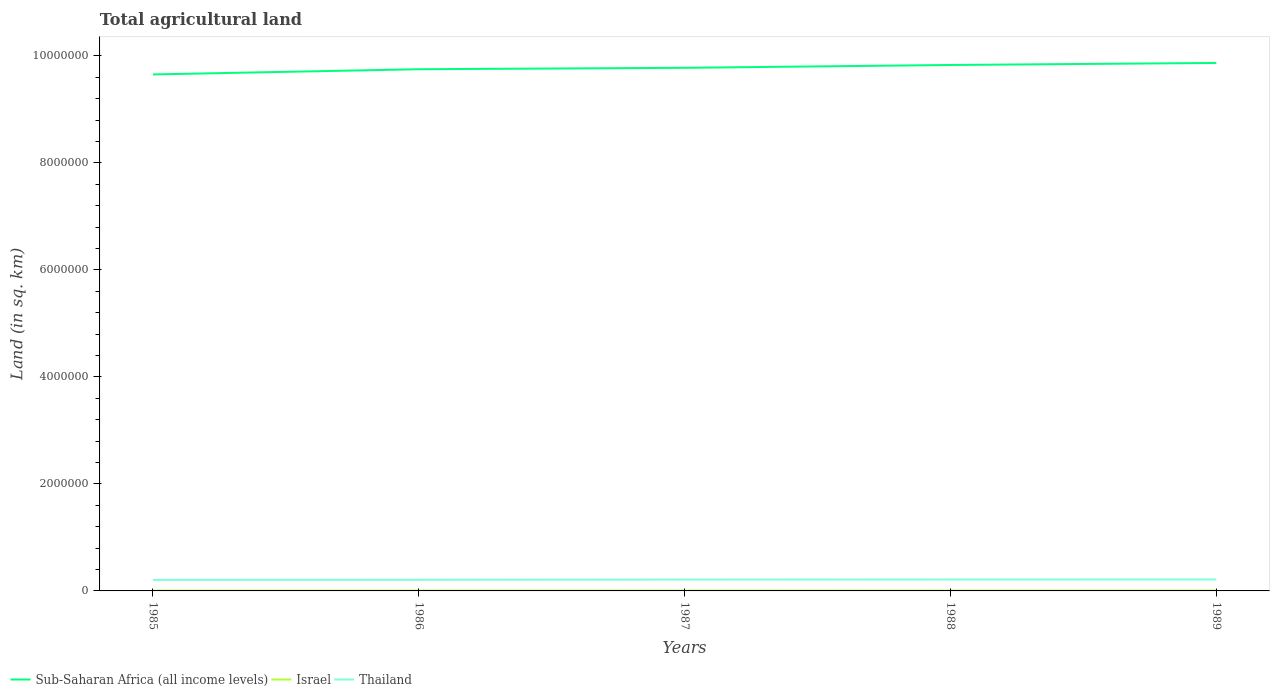How many different coloured lines are there?
Provide a short and direct response. 3. Does the line corresponding to Thailand intersect with the line corresponding to Israel?
Offer a terse response. No. Is the number of lines equal to the number of legend labels?
Offer a very short reply. Yes. Across all years, what is the maximum total agricultural land in Sub-Saharan Africa (all income levels)?
Your response must be concise. 9.65e+06. In which year was the total agricultural land in Israel maximum?
Your response must be concise. 1985. What is the total total agricultural land in Sub-Saharan Africa (all income levels) in the graph?
Your answer should be compact. -2.15e+05. What is the difference between the highest and the second highest total agricultural land in Thailand?
Your answer should be compact. 7600. How many years are there in the graph?
Make the answer very short. 5. What is the difference between two consecutive major ticks on the Y-axis?
Provide a succinct answer. 2.00e+06. Does the graph contain grids?
Offer a terse response. No. How many legend labels are there?
Your answer should be very brief. 3. How are the legend labels stacked?
Offer a very short reply. Horizontal. What is the title of the graph?
Offer a very short reply. Total agricultural land. Does "Benin" appear as one of the legend labels in the graph?
Give a very brief answer. No. What is the label or title of the Y-axis?
Keep it short and to the point. Land (in sq. km). What is the Land (in sq. km) of Sub-Saharan Africa (all income levels) in 1985?
Provide a short and direct response. 9.65e+06. What is the Land (in sq. km) of Israel in 1985?
Keep it short and to the point. 5750. What is the Land (in sq. km) in Thailand in 1985?
Your response must be concise. 2.06e+05. What is the Land (in sq. km) of Sub-Saharan Africa (all income levels) in 1986?
Provide a short and direct response. 9.75e+06. What is the Land (in sq. km) in Israel in 1986?
Provide a succinct answer. 5790. What is the Land (in sq. km) of Thailand in 1986?
Your answer should be compact. 2.08e+05. What is the Land (in sq. km) in Sub-Saharan Africa (all income levels) in 1987?
Your response must be concise. 9.78e+06. What is the Land (in sq. km) in Israel in 1987?
Your response must be concise. 5770. What is the Land (in sq. km) in Thailand in 1987?
Offer a terse response. 2.12e+05. What is the Land (in sq. km) of Sub-Saharan Africa (all income levels) in 1988?
Keep it short and to the point. 9.83e+06. What is the Land (in sq. km) of Israel in 1988?
Ensure brevity in your answer.  5760. What is the Land (in sq. km) in Thailand in 1988?
Keep it short and to the point. 2.13e+05. What is the Land (in sq. km) of Sub-Saharan Africa (all income levels) in 1989?
Provide a succinct answer. 9.87e+06. What is the Land (in sq. km) in Israel in 1989?
Offer a very short reply. 5750. What is the Land (in sq. km) in Thailand in 1989?
Give a very brief answer. 2.13e+05. Across all years, what is the maximum Land (in sq. km) in Sub-Saharan Africa (all income levels)?
Give a very brief answer. 9.87e+06. Across all years, what is the maximum Land (in sq. km) of Israel?
Provide a short and direct response. 5790. Across all years, what is the maximum Land (in sq. km) of Thailand?
Your answer should be very brief. 2.13e+05. Across all years, what is the minimum Land (in sq. km) in Sub-Saharan Africa (all income levels)?
Your answer should be very brief. 9.65e+06. Across all years, what is the minimum Land (in sq. km) of Israel?
Make the answer very short. 5750. Across all years, what is the minimum Land (in sq. km) in Thailand?
Make the answer very short. 2.06e+05. What is the total Land (in sq. km) of Sub-Saharan Africa (all income levels) in the graph?
Keep it short and to the point. 4.89e+07. What is the total Land (in sq. km) in Israel in the graph?
Make the answer very short. 2.88e+04. What is the total Land (in sq. km) in Thailand in the graph?
Your response must be concise. 1.05e+06. What is the difference between the Land (in sq. km) of Sub-Saharan Africa (all income levels) in 1985 and that in 1986?
Provide a succinct answer. -9.73e+04. What is the difference between the Land (in sq. km) in Thailand in 1985 and that in 1986?
Ensure brevity in your answer.  -1980. What is the difference between the Land (in sq. km) in Sub-Saharan Africa (all income levels) in 1985 and that in 1987?
Your answer should be very brief. -1.24e+05. What is the difference between the Land (in sq. km) of Thailand in 1985 and that in 1987?
Ensure brevity in your answer.  -6630. What is the difference between the Land (in sq. km) in Sub-Saharan Africa (all income levels) in 1985 and that in 1988?
Your answer should be very brief. -1.77e+05. What is the difference between the Land (in sq. km) of Israel in 1985 and that in 1988?
Give a very brief answer. -10. What is the difference between the Land (in sq. km) in Thailand in 1985 and that in 1988?
Your answer should be compact. -7530. What is the difference between the Land (in sq. km) in Sub-Saharan Africa (all income levels) in 1985 and that in 1989?
Provide a short and direct response. -2.15e+05. What is the difference between the Land (in sq. km) of Thailand in 1985 and that in 1989?
Offer a very short reply. -7600. What is the difference between the Land (in sq. km) in Sub-Saharan Africa (all income levels) in 1986 and that in 1987?
Keep it short and to the point. -2.64e+04. What is the difference between the Land (in sq. km) in Thailand in 1986 and that in 1987?
Offer a terse response. -4650. What is the difference between the Land (in sq. km) in Sub-Saharan Africa (all income levels) in 1986 and that in 1988?
Keep it short and to the point. -7.95e+04. What is the difference between the Land (in sq. km) of Thailand in 1986 and that in 1988?
Your answer should be very brief. -5550. What is the difference between the Land (in sq. km) in Sub-Saharan Africa (all income levels) in 1986 and that in 1989?
Provide a succinct answer. -1.17e+05. What is the difference between the Land (in sq. km) in Israel in 1986 and that in 1989?
Your response must be concise. 40. What is the difference between the Land (in sq. km) in Thailand in 1986 and that in 1989?
Give a very brief answer. -5620. What is the difference between the Land (in sq. km) of Sub-Saharan Africa (all income levels) in 1987 and that in 1988?
Provide a short and direct response. -5.31e+04. What is the difference between the Land (in sq. km) of Israel in 1987 and that in 1988?
Offer a terse response. 10. What is the difference between the Land (in sq. km) of Thailand in 1987 and that in 1988?
Keep it short and to the point. -900. What is the difference between the Land (in sq. km) in Sub-Saharan Africa (all income levels) in 1987 and that in 1989?
Provide a succinct answer. -9.09e+04. What is the difference between the Land (in sq. km) in Israel in 1987 and that in 1989?
Provide a succinct answer. 20. What is the difference between the Land (in sq. km) of Thailand in 1987 and that in 1989?
Make the answer very short. -970. What is the difference between the Land (in sq. km) in Sub-Saharan Africa (all income levels) in 1988 and that in 1989?
Keep it short and to the point. -3.78e+04. What is the difference between the Land (in sq. km) of Israel in 1988 and that in 1989?
Make the answer very short. 10. What is the difference between the Land (in sq. km) of Thailand in 1988 and that in 1989?
Your answer should be compact. -70. What is the difference between the Land (in sq. km) of Sub-Saharan Africa (all income levels) in 1985 and the Land (in sq. km) of Israel in 1986?
Give a very brief answer. 9.65e+06. What is the difference between the Land (in sq. km) in Sub-Saharan Africa (all income levels) in 1985 and the Land (in sq. km) in Thailand in 1986?
Provide a succinct answer. 9.45e+06. What is the difference between the Land (in sq. km) in Israel in 1985 and the Land (in sq. km) in Thailand in 1986?
Your answer should be compact. -2.02e+05. What is the difference between the Land (in sq. km) of Sub-Saharan Africa (all income levels) in 1985 and the Land (in sq. km) of Israel in 1987?
Your response must be concise. 9.65e+06. What is the difference between the Land (in sq. km) in Sub-Saharan Africa (all income levels) in 1985 and the Land (in sq. km) in Thailand in 1987?
Keep it short and to the point. 9.44e+06. What is the difference between the Land (in sq. km) in Israel in 1985 and the Land (in sq. km) in Thailand in 1987?
Give a very brief answer. -2.07e+05. What is the difference between the Land (in sq. km) of Sub-Saharan Africa (all income levels) in 1985 and the Land (in sq. km) of Israel in 1988?
Keep it short and to the point. 9.65e+06. What is the difference between the Land (in sq. km) of Sub-Saharan Africa (all income levels) in 1985 and the Land (in sq. km) of Thailand in 1988?
Provide a succinct answer. 9.44e+06. What is the difference between the Land (in sq. km) of Israel in 1985 and the Land (in sq. km) of Thailand in 1988?
Provide a succinct answer. -2.08e+05. What is the difference between the Land (in sq. km) in Sub-Saharan Africa (all income levels) in 1985 and the Land (in sq. km) in Israel in 1989?
Give a very brief answer. 9.65e+06. What is the difference between the Land (in sq. km) of Sub-Saharan Africa (all income levels) in 1985 and the Land (in sq. km) of Thailand in 1989?
Give a very brief answer. 9.44e+06. What is the difference between the Land (in sq. km) of Israel in 1985 and the Land (in sq. km) of Thailand in 1989?
Your answer should be compact. -2.08e+05. What is the difference between the Land (in sq. km) of Sub-Saharan Africa (all income levels) in 1986 and the Land (in sq. km) of Israel in 1987?
Make the answer very short. 9.75e+06. What is the difference between the Land (in sq. km) of Sub-Saharan Africa (all income levels) in 1986 and the Land (in sq. km) of Thailand in 1987?
Give a very brief answer. 9.54e+06. What is the difference between the Land (in sq. km) of Israel in 1986 and the Land (in sq. km) of Thailand in 1987?
Provide a short and direct response. -2.07e+05. What is the difference between the Land (in sq. km) of Sub-Saharan Africa (all income levels) in 1986 and the Land (in sq. km) of Israel in 1988?
Your answer should be compact. 9.75e+06. What is the difference between the Land (in sq. km) of Sub-Saharan Africa (all income levels) in 1986 and the Land (in sq. km) of Thailand in 1988?
Give a very brief answer. 9.54e+06. What is the difference between the Land (in sq. km) in Israel in 1986 and the Land (in sq. km) in Thailand in 1988?
Provide a succinct answer. -2.08e+05. What is the difference between the Land (in sq. km) of Sub-Saharan Africa (all income levels) in 1986 and the Land (in sq. km) of Israel in 1989?
Your answer should be compact. 9.75e+06. What is the difference between the Land (in sq. km) of Sub-Saharan Africa (all income levels) in 1986 and the Land (in sq. km) of Thailand in 1989?
Your answer should be compact. 9.54e+06. What is the difference between the Land (in sq. km) in Israel in 1986 and the Land (in sq. km) in Thailand in 1989?
Your answer should be very brief. -2.08e+05. What is the difference between the Land (in sq. km) in Sub-Saharan Africa (all income levels) in 1987 and the Land (in sq. km) in Israel in 1988?
Ensure brevity in your answer.  9.77e+06. What is the difference between the Land (in sq. km) in Sub-Saharan Africa (all income levels) in 1987 and the Land (in sq. km) in Thailand in 1988?
Keep it short and to the point. 9.56e+06. What is the difference between the Land (in sq. km) of Israel in 1987 and the Land (in sq. km) of Thailand in 1988?
Offer a very short reply. -2.08e+05. What is the difference between the Land (in sq. km) in Sub-Saharan Africa (all income levels) in 1987 and the Land (in sq. km) in Israel in 1989?
Your answer should be compact. 9.77e+06. What is the difference between the Land (in sq. km) in Sub-Saharan Africa (all income levels) in 1987 and the Land (in sq. km) in Thailand in 1989?
Your answer should be compact. 9.56e+06. What is the difference between the Land (in sq. km) of Israel in 1987 and the Land (in sq. km) of Thailand in 1989?
Provide a succinct answer. -2.08e+05. What is the difference between the Land (in sq. km) of Sub-Saharan Africa (all income levels) in 1988 and the Land (in sq. km) of Israel in 1989?
Your answer should be compact. 9.83e+06. What is the difference between the Land (in sq. km) in Sub-Saharan Africa (all income levels) in 1988 and the Land (in sq. km) in Thailand in 1989?
Make the answer very short. 9.62e+06. What is the difference between the Land (in sq. km) of Israel in 1988 and the Land (in sq. km) of Thailand in 1989?
Give a very brief answer. -2.08e+05. What is the average Land (in sq. km) in Sub-Saharan Africa (all income levels) per year?
Ensure brevity in your answer.  9.78e+06. What is the average Land (in sq. km) in Israel per year?
Make the answer very short. 5764. What is the average Land (in sq. km) of Thailand per year?
Keep it short and to the point. 2.11e+05. In the year 1985, what is the difference between the Land (in sq. km) in Sub-Saharan Africa (all income levels) and Land (in sq. km) in Israel?
Give a very brief answer. 9.65e+06. In the year 1985, what is the difference between the Land (in sq. km) of Sub-Saharan Africa (all income levels) and Land (in sq. km) of Thailand?
Provide a succinct answer. 9.45e+06. In the year 1985, what is the difference between the Land (in sq. km) in Israel and Land (in sq. km) in Thailand?
Keep it short and to the point. -2.00e+05. In the year 1986, what is the difference between the Land (in sq. km) of Sub-Saharan Africa (all income levels) and Land (in sq. km) of Israel?
Ensure brevity in your answer.  9.75e+06. In the year 1986, what is the difference between the Land (in sq. km) of Sub-Saharan Africa (all income levels) and Land (in sq. km) of Thailand?
Make the answer very short. 9.54e+06. In the year 1986, what is the difference between the Land (in sq. km) of Israel and Land (in sq. km) of Thailand?
Provide a succinct answer. -2.02e+05. In the year 1987, what is the difference between the Land (in sq. km) of Sub-Saharan Africa (all income levels) and Land (in sq. km) of Israel?
Ensure brevity in your answer.  9.77e+06. In the year 1987, what is the difference between the Land (in sq. km) in Sub-Saharan Africa (all income levels) and Land (in sq. km) in Thailand?
Provide a short and direct response. 9.57e+06. In the year 1987, what is the difference between the Land (in sq. km) of Israel and Land (in sq. km) of Thailand?
Your answer should be very brief. -2.07e+05. In the year 1988, what is the difference between the Land (in sq. km) of Sub-Saharan Africa (all income levels) and Land (in sq. km) of Israel?
Make the answer very short. 9.83e+06. In the year 1988, what is the difference between the Land (in sq. km) of Sub-Saharan Africa (all income levels) and Land (in sq. km) of Thailand?
Give a very brief answer. 9.62e+06. In the year 1988, what is the difference between the Land (in sq. km) in Israel and Land (in sq. km) in Thailand?
Offer a very short reply. -2.08e+05. In the year 1989, what is the difference between the Land (in sq. km) of Sub-Saharan Africa (all income levels) and Land (in sq. km) of Israel?
Keep it short and to the point. 9.86e+06. In the year 1989, what is the difference between the Land (in sq. km) of Sub-Saharan Africa (all income levels) and Land (in sq. km) of Thailand?
Provide a succinct answer. 9.66e+06. In the year 1989, what is the difference between the Land (in sq. km) of Israel and Land (in sq. km) of Thailand?
Offer a very short reply. -2.08e+05. What is the ratio of the Land (in sq. km) of Sub-Saharan Africa (all income levels) in 1985 to that in 1986?
Offer a terse response. 0.99. What is the ratio of the Land (in sq. km) of Israel in 1985 to that in 1986?
Keep it short and to the point. 0.99. What is the ratio of the Land (in sq. km) of Sub-Saharan Africa (all income levels) in 1985 to that in 1987?
Keep it short and to the point. 0.99. What is the ratio of the Land (in sq. km) of Thailand in 1985 to that in 1987?
Give a very brief answer. 0.97. What is the ratio of the Land (in sq. km) in Sub-Saharan Africa (all income levels) in 1985 to that in 1988?
Your response must be concise. 0.98. What is the ratio of the Land (in sq. km) in Israel in 1985 to that in 1988?
Provide a succinct answer. 1. What is the ratio of the Land (in sq. km) in Thailand in 1985 to that in 1988?
Make the answer very short. 0.96. What is the ratio of the Land (in sq. km) in Sub-Saharan Africa (all income levels) in 1985 to that in 1989?
Keep it short and to the point. 0.98. What is the ratio of the Land (in sq. km) of Thailand in 1985 to that in 1989?
Your response must be concise. 0.96. What is the ratio of the Land (in sq. km) in Thailand in 1986 to that in 1987?
Your response must be concise. 0.98. What is the ratio of the Land (in sq. km) in Sub-Saharan Africa (all income levels) in 1986 to that in 1988?
Your response must be concise. 0.99. What is the ratio of the Land (in sq. km) of Sub-Saharan Africa (all income levels) in 1986 to that in 1989?
Your answer should be compact. 0.99. What is the ratio of the Land (in sq. km) in Thailand in 1986 to that in 1989?
Give a very brief answer. 0.97. What is the ratio of the Land (in sq. km) in Sub-Saharan Africa (all income levels) in 1987 to that in 1988?
Provide a short and direct response. 0.99. What is the ratio of the Land (in sq. km) in Sub-Saharan Africa (all income levels) in 1987 to that in 1989?
Provide a succinct answer. 0.99. What is the ratio of the Land (in sq. km) of Thailand in 1987 to that in 1989?
Provide a short and direct response. 1. What is the ratio of the Land (in sq. km) in Sub-Saharan Africa (all income levels) in 1988 to that in 1989?
Offer a very short reply. 1. What is the ratio of the Land (in sq. km) in Israel in 1988 to that in 1989?
Provide a short and direct response. 1. What is the difference between the highest and the second highest Land (in sq. km) of Sub-Saharan Africa (all income levels)?
Your answer should be compact. 3.78e+04. What is the difference between the highest and the second highest Land (in sq. km) of Thailand?
Your answer should be compact. 70. What is the difference between the highest and the lowest Land (in sq. km) of Sub-Saharan Africa (all income levels)?
Your response must be concise. 2.15e+05. What is the difference between the highest and the lowest Land (in sq. km) of Israel?
Offer a very short reply. 40. What is the difference between the highest and the lowest Land (in sq. km) in Thailand?
Your response must be concise. 7600. 